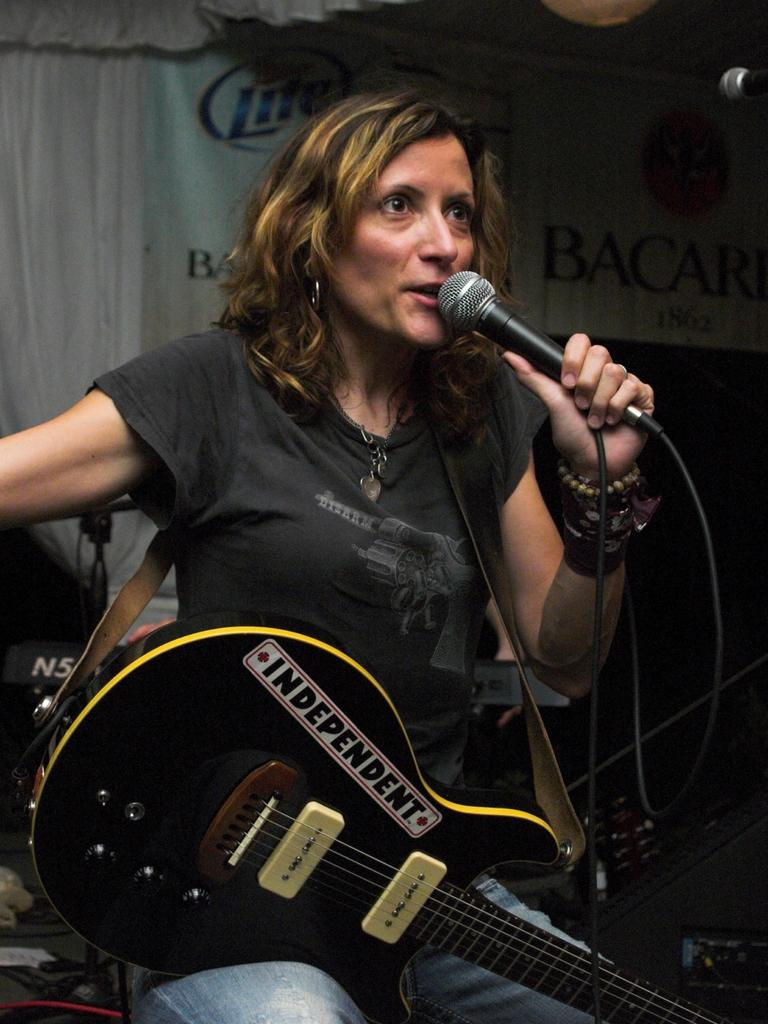What is the woman in the image holding in her hands? The woman is holding a microphone and a guitar in her hands. What might the woman be doing in the image? The woman might be performing or singing, given that she is holding a microphone and a guitar. How many ducks are visible in the image? There are no ducks present in the image. What type of station is the woman using to perform in the image? The image does not show any station or specific location for the performance. 